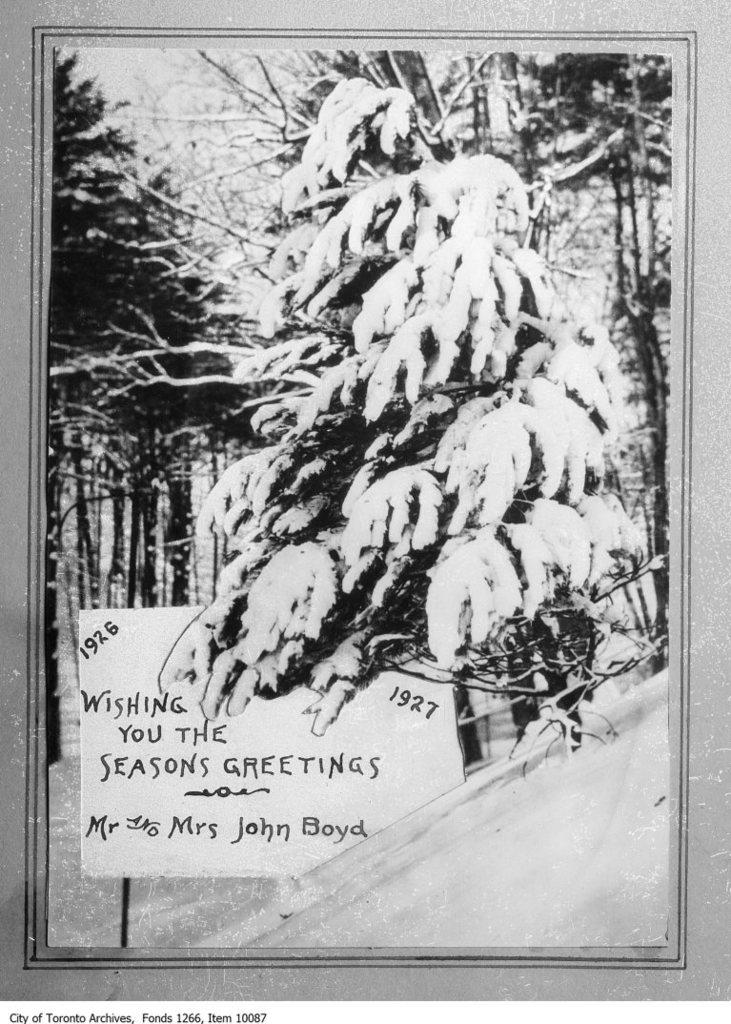What type of vegetation can be seen in the image? There are trees in the image. What object has writing on it in the image? There is something written on a board in the image. What color scheme is used in the image? The image is black and white in color. Can you see any bears blowing bubbles in the image? There are no bears or bubbles present in the image. Is there a window visible in the image? There is no window mentioned in the provided facts, so we cannot determine if one is present in the image. 